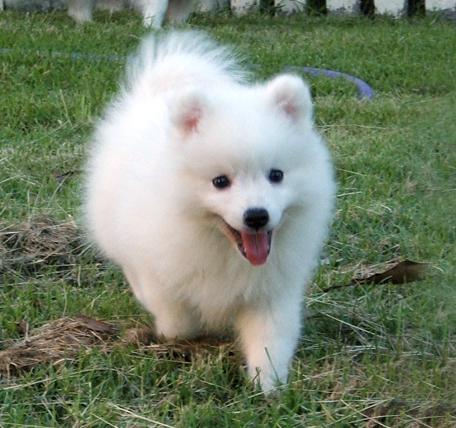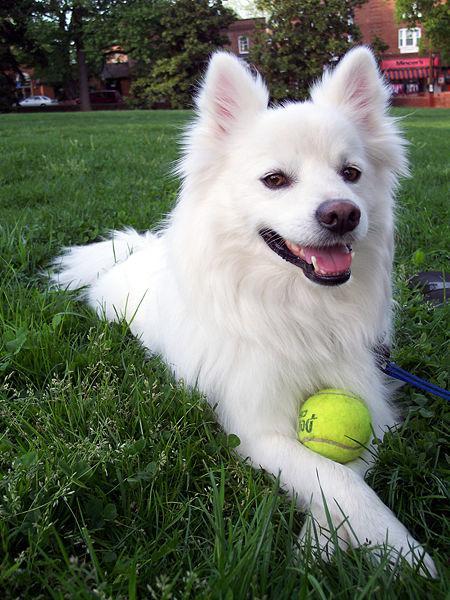The first image is the image on the left, the second image is the image on the right. Analyze the images presented: Is the assertion "The right image contains exactly two white dogs." valid? Answer yes or no. No. The first image is the image on the left, the second image is the image on the right. Analyze the images presented: Is the assertion "One image contains exactly two dogs side-by-side, and the other features one non-standing dog." valid? Answer yes or no. No. 